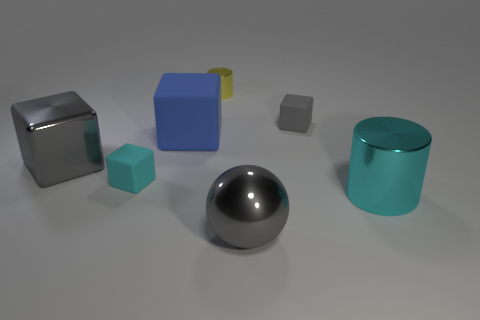Subtract all large gray shiny blocks. How many blocks are left? 3 Subtract 2 blocks. How many blocks are left? 2 Add 1 small cyan things. How many objects exist? 8 Subtract all cylinders. How many objects are left? 5 Add 2 cyan rubber objects. How many cyan rubber objects are left? 3 Add 1 gray shiny blocks. How many gray shiny blocks exist? 2 Subtract all cyan cylinders. How many cylinders are left? 1 Subtract 0 cyan balls. How many objects are left? 7 Subtract all yellow cylinders. Subtract all gray cubes. How many cylinders are left? 1 Subtract all blue blocks. How many blue spheres are left? 0 